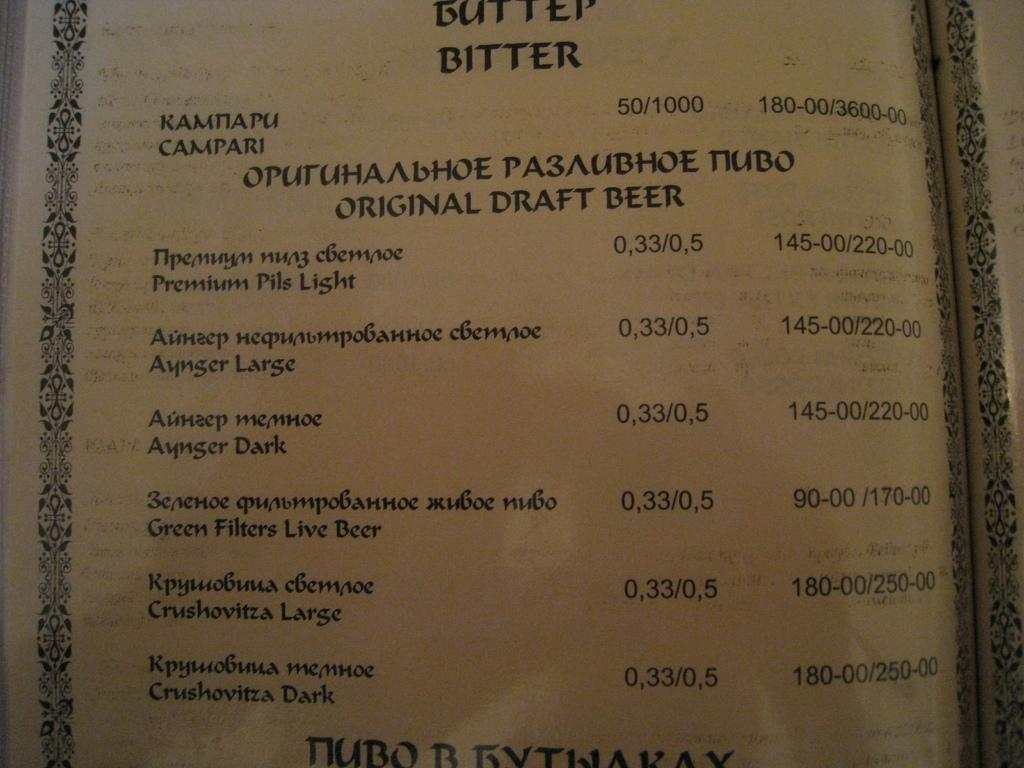<image>
Describe the image concisely. A restaurant menu with several choices for draft beer. 